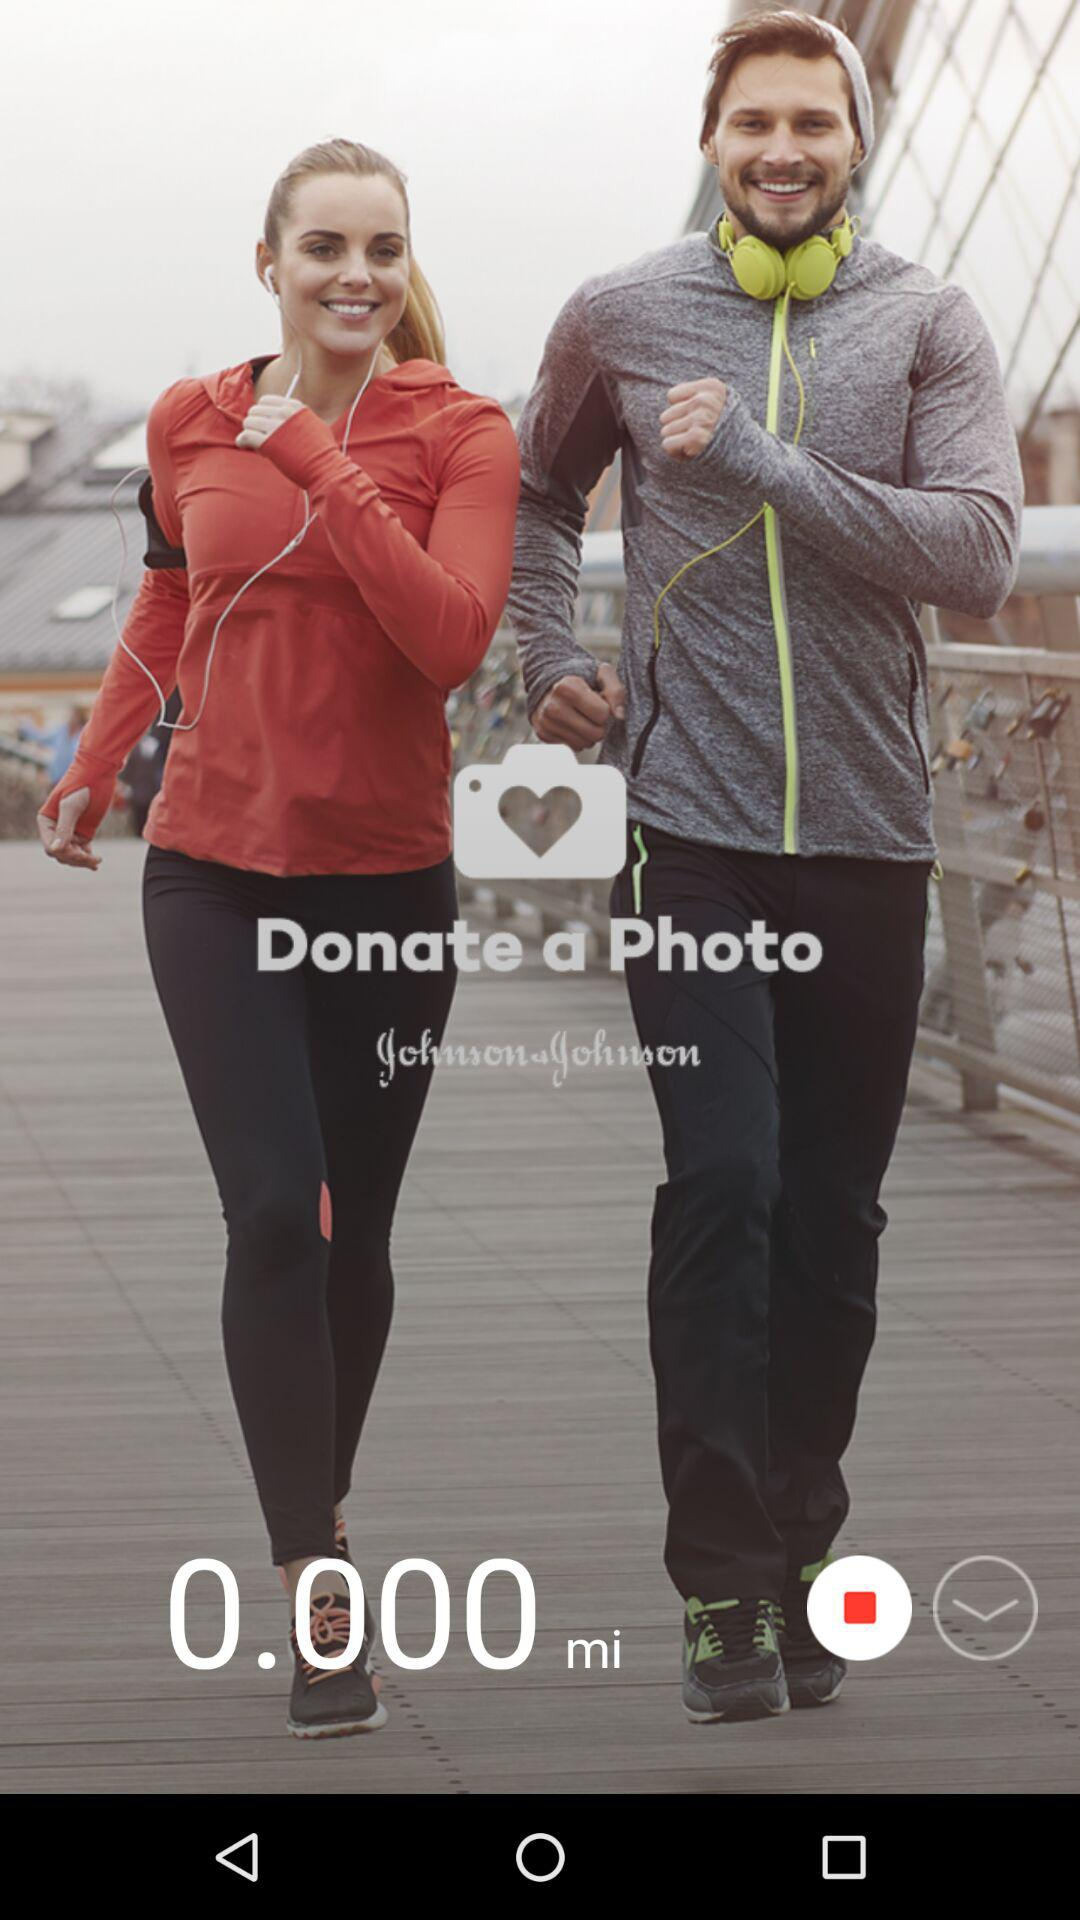How many miles are shown there? There are 0.000 miles shown. 